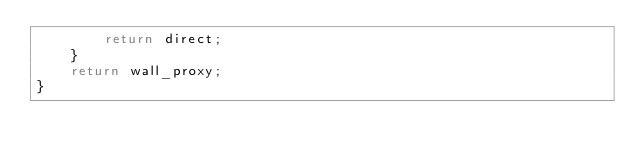<code> <loc_0><loc_0><loc_500><loc_500><_JavaScript_>        return direct;
    }
    return wall_proxy;
}</code> 